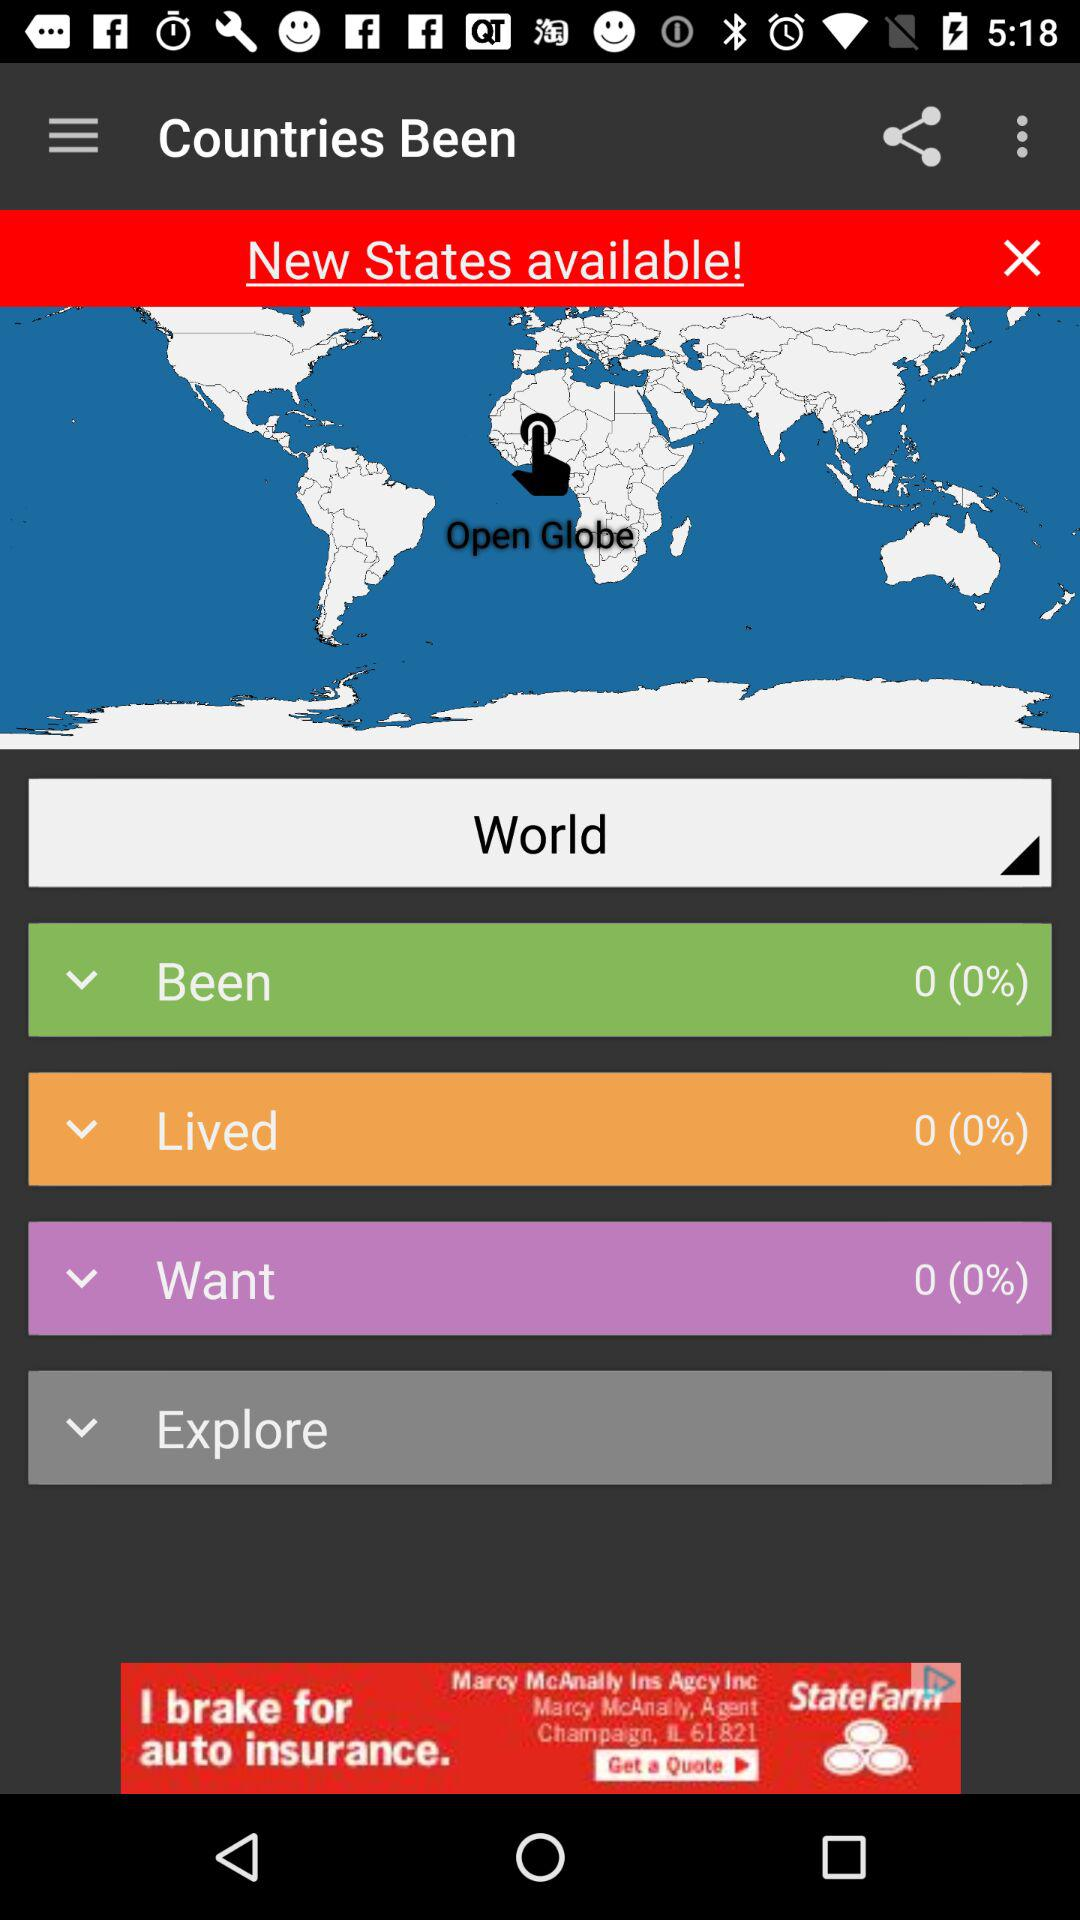What is the count for the countries we have been to? You have been to 0 countries. 